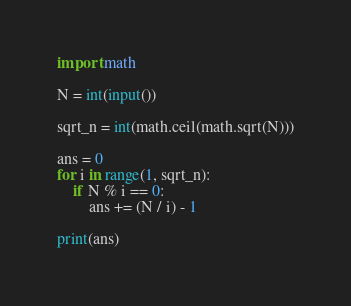Convert code to text. <code><loc_0><loc_0><loc_500><loc_500><_Python_>import math

N = int(input())

sqrt_n = int(math.ceil(math.sqrt(N)))

ans = 0
for i in range(1, sqrt_n):
    if N % i == 0:
        ans += (N / i) - 1

print(ans)</code> 